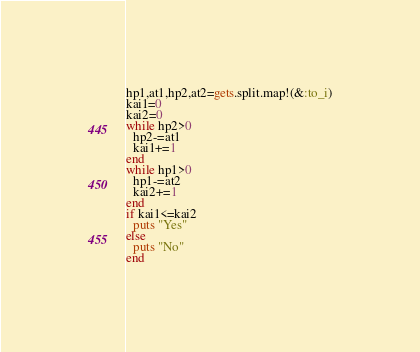<code> <loc_0><loc_0><loc_500><loc_500><_Ruby_>hp1,at1,hp2,at2=gets.split.map!(&:to_i)
kai1=0
kai2=0
while hp2>0
  hp2-=at1
  kai1+=1
end
while hp1>0
  hp1-=at2
  kai2+=1
end
if kai1<=kai2
  puts "Yes"
else
  puts "No"
end
</code> 